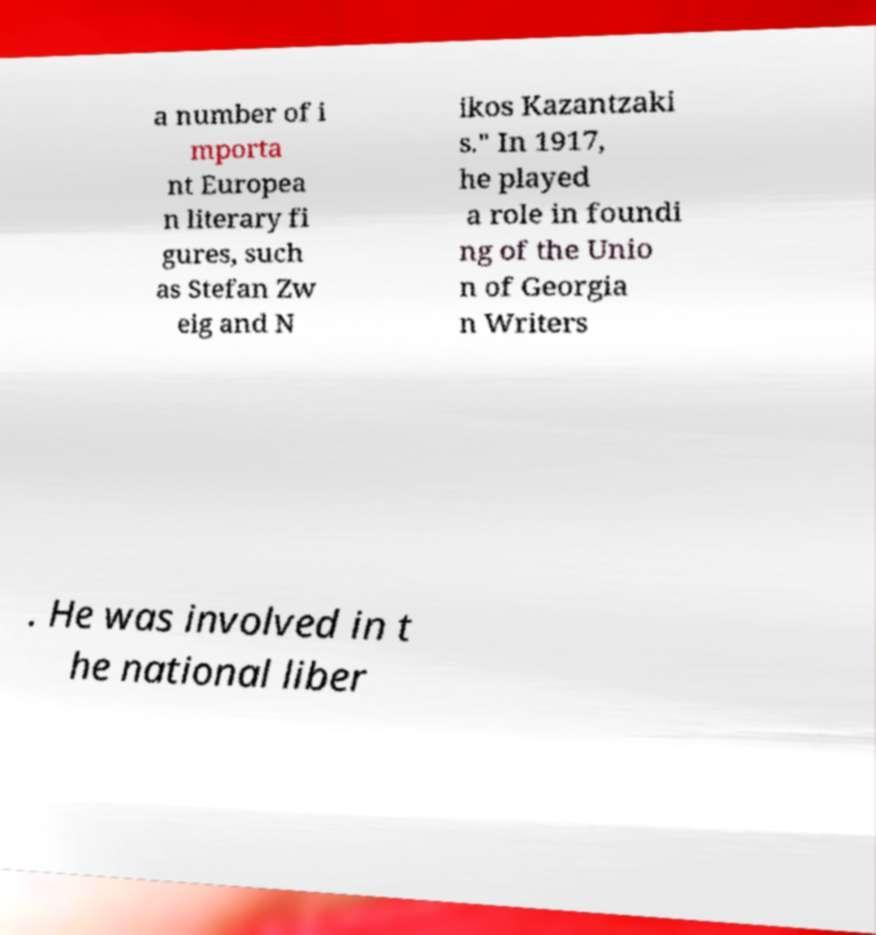Can you read and provide the text displayed in the image?This photo seems to have some interesting text. Can you extract and type it out for me? a number of i mporta nt Europea n literary fi gures, such as Stefan Zw eig and N ikos Kazantzaki s." In 1917, he played a role in foundi ng of the Unio n of Georgia n Writers . He was involved in t he national liber 